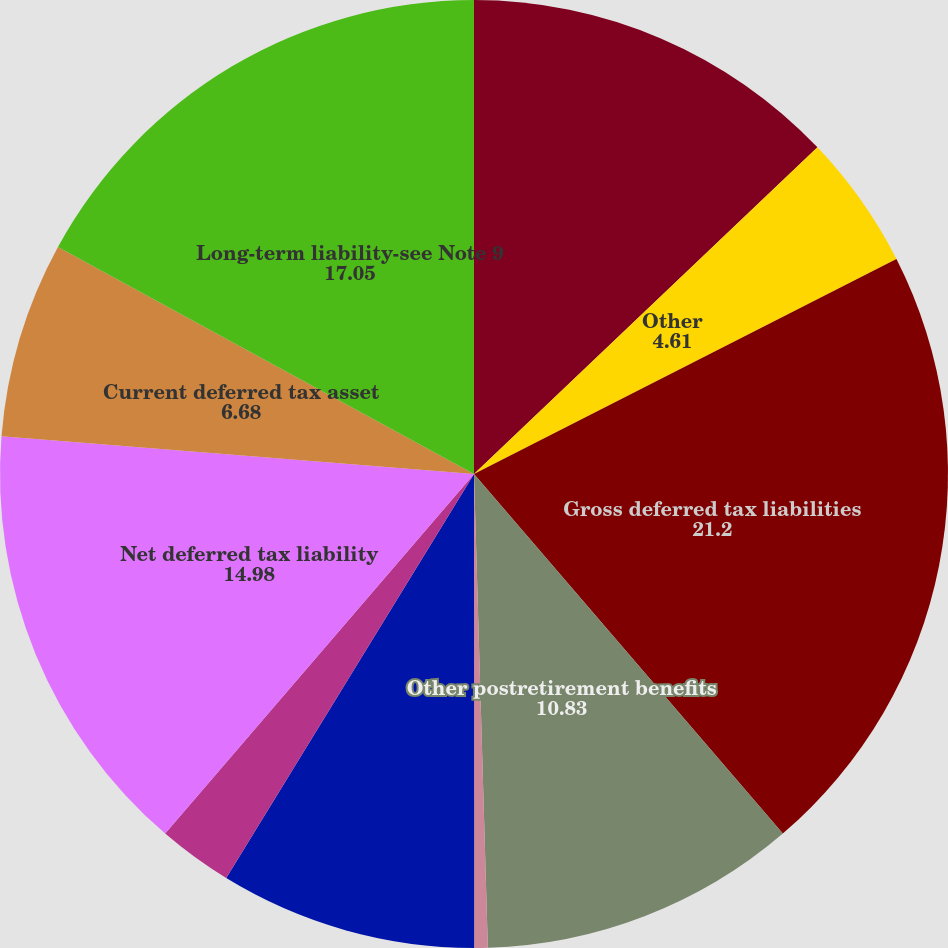<chart> <loc_0><loc_0><loc_500><loc_500><pie_chart><fcel>Pensionplans<fcel>Other<fcel>Gross deferred tax liabilities<fcel>Other postretirement benefits<fcel>Loss and credit carryforwards<fcel>Insurance reserves<fcel>Vacation pay accrual<fcel>Net deferred tax liability<fcel>Current deferred tax asset<fcel>Long-term liability-see Note 9<nl><fcel>12.9%<fcel>4.61%<fcel>21.2%<fcel>10.83%<fcel>0.46%<fcel>8.76%<fcel>2.54%<fcel>14.98%<fcel>6.68%<fcel>17.05%<nl></chart> 